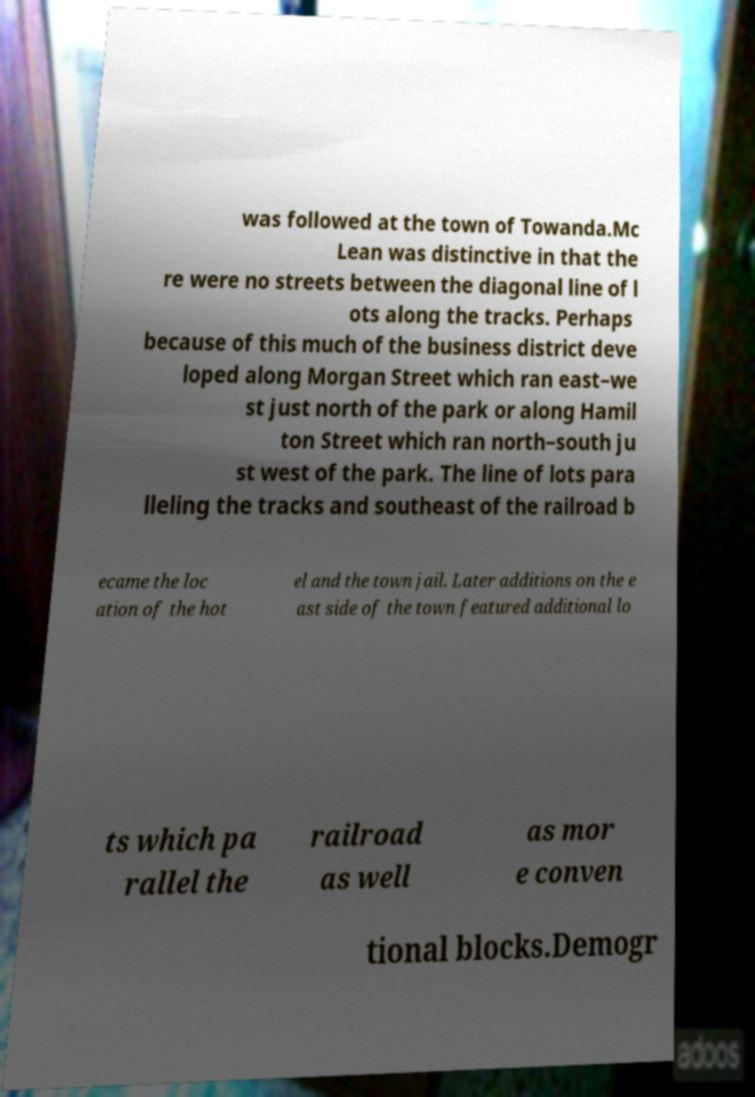Could you assist in decoding the text presented in this image and type it out clearly? was followed at the town of Towanda.Mc Lean was distinctive in that the re were no streets between the diagonal line of l ots along the tracks. Perhaps because of this much of the business district deve loped along Morgan Street which ran east–we st just north of the park or along Hamil ton Street which ran north–south ju st west of the park. The line of lots para lleling the tracks and southeast of the railroad b ecame the loc ation of the hot el and the town jail. Later additions on the e ast side of the town featured additional lo ts which pa rallel the railroad as well as mor e conven tional blocks.Demogr 